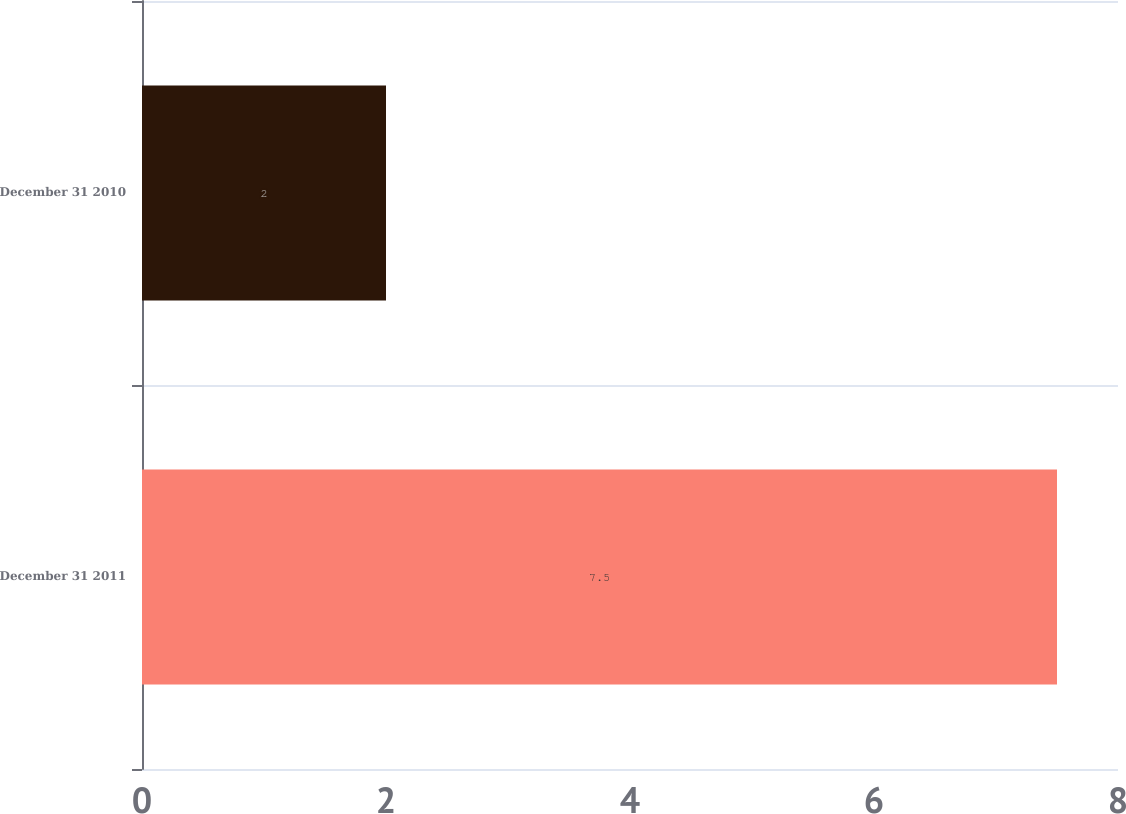<chart> <loc_0><loc_0><loc_500><loc_500><bar_chart><fcel>December 31 2011<fcel>December 31 2010<nl><fcel>7.5<fcel>2<nl></chart> 